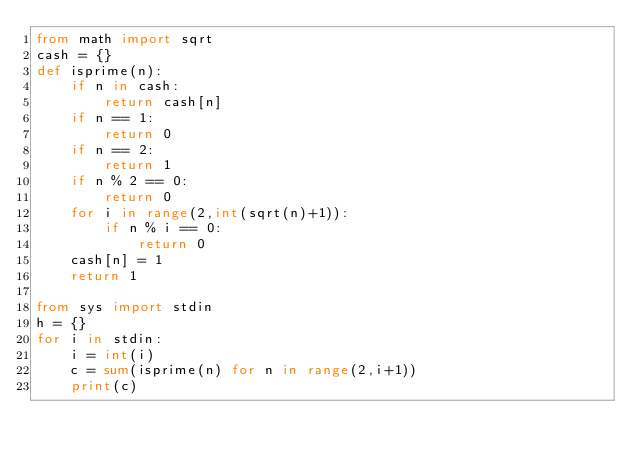Convert code to text. <code><loc_0><loc_0><loc_500><loc_500><_Python_>from math import sqrt
cash = {}
def isprime(n):
    if n in cash:
        return cash[n]
    if n == 1:
        return 0
    if n == 2:
        return 1
    if n % 2 == 0:
        return 0
    for i in range(2,int(sqrt(n)+1)):
        if n % i == 0:
            return 0
    cash[n] = 1
    return 1

from sys import stdin
h = {}
for i in stdin:
    i = int(i)
    c = sum(isprime(n) for n in range(2,i+1))
    print(c)</code> 